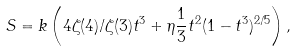<formula> <loc_0><loc_0><loc_500><loc_500>S = k \left ( 4 \zeta ( 4 ) / \zeta ( 3 ) t ^ { 3 } + \eta \frac { 1 } { 3 } t ^ { 2 } ( 1 - t ^ { 3 } ) ^ { 2 / 5 } \right ) ,</formula> 